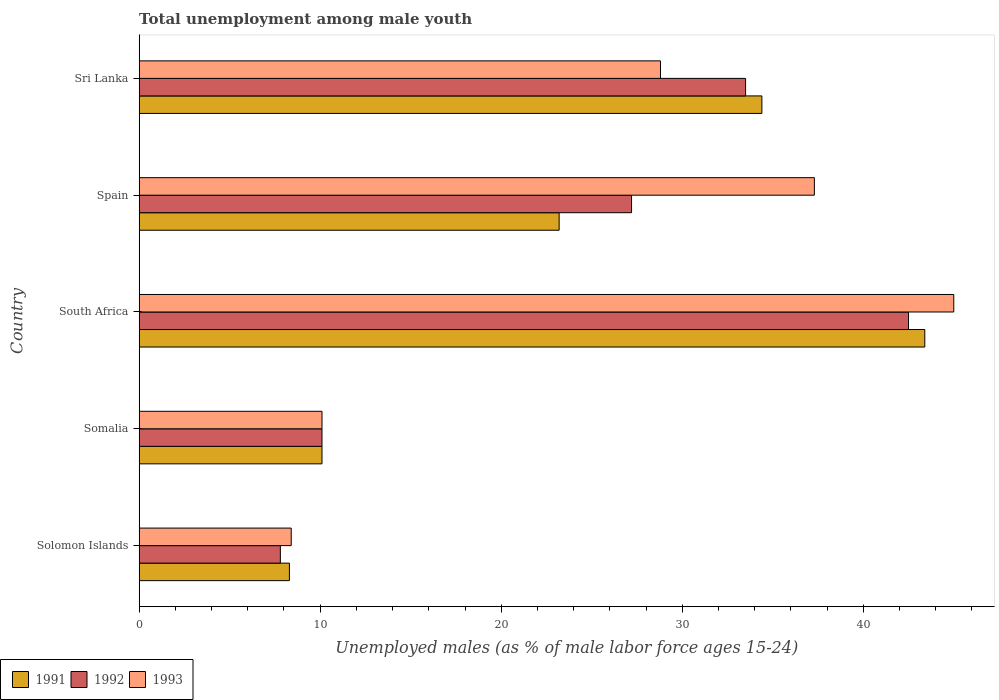How many different coloured bars are there?
Offer a very short reply. 3. Are the number of bars per tick equal to the number of legend labels?
Give a very brief answer. Yes. Are the number of bars on each tick of the Y-axis equal?
Provide a short and direct response. Yes. How many bars are there on the 4th tick from the top?
Your response must be concise. 3. What is the label of the 1st group of bars from the top?
Give a very brief answer. Sri Lanka. What is the percentage of unemployed males in in 1992 in Sri Lanka?
Ensure brevity in your answer.  33.5. Across all countries, what is the maximum percentage of unemployed males in in 1992?
Provide a succinct answer. 42.5. Across all countries, what is the minimum percentage of unemployed males in in 1993?
Provide a succinct answer. 8.4. In which country was the percentage of unemployed males in in 1992 maximum?
Offer a terse response. South Africa. In which country was the percentage of unemployed males in in 1993 minimum?
Provide a short and direct response. Solomon Islands. What is the total percentage of unemployed males in in 1993 in the graph?
Keep it short and to the point. 129.6. What is the difference between the percentage of unemployed males in in 1992 in Solomon Islands and that in Sri Lanka?
Keep it short and to the point. -25.7. What is the difference between the percentage of unemployed males in in 1992 in Solomon Islands and the percentage of unemployed males in in 1991 in South Africa?
Keep it short and to the point. -35.6. What is the average percentage of unemployed males in in 1993 per country?
Provide a succinct answer. 25.92. What is the difference between the percentage of unemployed males in in 1992 and percentage of unemployed males in in 1993 in Sri Lanka?
Make the answer very short. 4.7. In how many countries, is the percentage of unemployed males in in 1991 greater than 8 %?
Provide a succinct answer. 5. What is the ratio of the percentage of unemployed males in in 1991 in Solomon Islands to that in South Africa?
Offer a terse response. 0.19. Is the percentage of unemployed males in in 1992 in Spain less than that in Sri Lanka?
Make the answer very short. Yes. Is the difference between the percentage of unemployed males in in 1992 in Somalia and South Africa greater than the difference between the percentage of unemployed males in in 1993 in Somalia and South Africa?
Offer a very short reply. Yes. What is the difference between the highest and the second highest percentage of unemployed males in in 1993?
Keep it short and to the point. 7.7. What is the difference between the highest and the lowest percentage of unemployed males in in 1991?
Keep it short and to the point. 35.1. In how many countries, is the percentage of unemployed males in in 1991 greater than the average percentage of unemployed males in in 1991 taken over all countries?
Your response must be concise. 2. Is the sum of the percentage of unemployed males in in 1993 in Solomon Islands and South Africa greater than the maximum percentage of unemployed males in in 1991 across all countries?
Your response must be concise. Yes. What does the 2nd bar from the top in Spain represents?
Give a very brief answer. 1992. What does the 1st bar from the bottom in South Africa represents?
Offer a very short reply. 1991. Is it the case that in every country, the sum of the percentage of unemployed males in in 1992 and percentage of unemployed males in in 1993 is greater than the percentage of unemployed males in in 1991?
Give a very brief answer. Yes. Are all the bars in the graph horizontal?
Keep it short and to the point. Yes. How many countries are there in the graph?
Provide a short and direct response. 5. What is the difference between two consecutive major ticks on the X-axis?
Ensure brevity in your answer.  10. Are the values on the major ticks of X-axis written in scientific E-notation?
Ensure brevity in your answer.  No. Where does the legend appear in the graph?
Make the answer very short. Bottom left. What is the title of the graph?
Provide a short and direct response. Total unemployment among male youth. What is the label or title of the X-axis?
Your answer should be very brief. Unemployed males (as % of male labor force ages 15-24). What is the Unemployed males (as % of male labor force ages 15-24) of 1991 in Solomon Islands?
Ensure brevity in your answer.  8.3. What is the Unemployed males (as % of male labor force ages 15-24) of 1992 in Solomon Islands?
Make the answer very short. 7.8. What is the Unemployed males (as % of male labor force ages 15-24) of 1993 in Solomon Islands?
Give a very brief answer. 8.4. What is the Unemployed males (as % of male labor force ages 15-24) of 1991 in Somalia?
Provide a succinct answer. 10.1. What is the Unemployed males (as % of male labor force ages 15-24) of 1992 in Somalia?
Keep it short and to the point. 10.1. What is the Unemployed males (as % of male labor force ages 15-24) in 1993 in Somalia?
Give a very brief answer. 10.1. What is the Unemployed males (as % of male labor force ages 15-24) in 1991 in South Africa?
Offer a very short reply. 43.4. What is the Unemployed males (as % of male labor force ages 15-24) in 1992 in South Africa?
Provide a short and direct response. 42.5. What is the Unemployed males (as % of male labor force ages 15-24) in 1993 in South Africa?
Offer a terse response. 45. What is the Unemployed males (as % of male labor force ages 15-24) of 1991 in Spain?
Give a very brief answer. 23.2. What is the Unemployed males (as % of male labor force ages 15-24) of 1992 in Spain?
Keep it short and to the point. 27.2. What is the Unemployed males (as % of male labor force ages 15-24) in 1993 in Spain?
Offer a very short reply. 37.3. What is the Unemployed males (as % of male labor force ages 15-24) in 1991 in Sri Lanka?
Your answer should be compact. 34.4. What is the Unemployed males (as % of male labor force ages 15-24) of 1992 in Sri Lanka?
Your answer should be very brief. 33.5. What is the Unemployed males (as % of male labor force ages 15-24) of 1993 in Sri Lanka?
Offer a terse response. 28.8. Across all countries, what is the maximum Unemployed males (as % of male labor force ages 15-24) of 1991?
Provide a succinct answer. 43.4. Across all countries, what is the maximum Unemployed males (as % of male labor force ages 15-24) in 1992?
Provide a succinct answer. 42.5. Across all countries, what is the minimum Unemployed males (as % of male labor force ages 15-24) of 1991?
Offer a very short reply. 8.3. Across all countries, what is the minimum Unemployed males (as % of male labor force ages 15-24) in 1992?
Provide a short and direct response. 7.8. Across all countries, what is the minimum Unemployed males (as % of male labor force ages 15-24) of 1993?
Provide a short and direct response. 8.4. What is the total Unemployed males (as % of male labor force ages 15-24) in 1991 in the graph?
Provide a succinct answer. 119.4. What is the total Unemployed males (as % of male labor force ages 15-24) in 1992 in the graph?
Make the answer very short. 121.1. What is the total Unemployed males (as % of male labor force ages 15-24) of 1993 in the graph?
Offer a terse response. 129.6. What is the difference between the Unemployed males (as % of male labor force ages 15-24) of 1991 in Solomon Islands and that in Somalia?
Your answer should be very brief. -1.8. What is the difference between the Unemployed males (as % of male labor force ages 15-24) of 1992 in Solomon Islands and that in Somalia?
Provide a succinct answer. -2.3. What is the difference between the Unemployed males (as % of male labor force ages 15-24) in 1991 in Solomon Islands and that in South Africa?
Make the answer very short. -35.1. What is the difference between the Unemployed males (as % of male labor force ages 15-24) in 1992 in Solomon Islands and that in South Africa?
Your answer should be very brief. -34.7. What is the difference between the Unemployed males (as % of male labor force ages 15-24) of 1993 in Solomon Islands and that in South Africa?
Give a very brief answer. -36.6. What is the difference between the Unemployed males (as % of male labor force ages 15-24) in 1991 in Solomon Islands and that in Spain?
Provide a short and direct response. -14.9. What is the difference between the Unemployed males (as % of male labor force ages 15-24) in 1992 in Solomon Islands and that in Spain?
Your answer should be compact. -19.4. What is the difference between the Unemployed males (as % of male labor force ages 15-24) in 1993 in Solomon Islands and that in Spain?
Provide a short and direct response. -28.9. What is the difference between the Unemployed males (as % of male labor force ages 15-24) in 1991 in Solomon Islands and that in Sri Lanka?
Make the answer very short. -26.1. What is the difference between the Unemployed males (as % of male labor force ages 15-24) in 1992 in Solomon Islands and that in Sri Lanka?
Your answer should be very brief. -25.7. What is the difference between the Unemployed males (as % of male labor force ages 15-24) in 1993 in Solomon Islands and that in Sri Lanka?
Offer a very short reply. -20.4. What is the difference between the Unemployed males (as % of male labor force ages 15-24) of 1991 in Somalia and that in South Africa?
Ensure brevity in your answer.  -33.3. What is the difference between the Unemployed males (as % of male labor force ages 15-24) of 1992 in Somalia and that in South Africa?
Your answer should be compact. -32.4. What is the difference between the Unemployed males (as % of male labor force ages 15-24) in 1993 in Somalia and that in South Africa?
Ensure brevity in your answer.  -34.9. What is the difference between the Unemployed males (as % of male labor force ages 15-24) in 1992 in Somalia and that in Spain?
Provide a short and direct response. -17.1. What is the difference between the Unemployed males (as % of male labor force ages 15-24) of 1993 in Somalia and that in Spain?
Keep it short and to the point. -27.2. What is the difference between the Unemployed males (as % of male labor force ages 15-24) of 1991 in Somalia and that in Sri Lanka?
Make the answer very short. -24.3. What is the difference between the Unemployed males (as % of male labor force ages 15-24) of 1992 in Somalia and that in Sri Lanka?
Offer a terse response. -23.4. What is the difference between the Unemployed males (as % of male labor force ages 15-24) in 1993 in Somalia and that in Sri Lanka?
Make the answer very short. -18.7. What is the difference between the Unemployed males (as % of male labor force ages 15-24) of 1991 in South Africa and that in Spain?
Keep it short and to the point. 20.2. What is the difference between the Unemployed males (as % of male labor force ages 15-24) of 1992 in South Africa and that in Spain?
Provide a succinct answer. 15.3. What is the difference between the Unemployed males (as % of male labor force ages 15-24) of 1992 in South Africa and that in Sri Lanka?
Your response must be concise. 9. What is the difference between the Unemployed males (as % of male labor force ages 15-24) in 1993 in South Africa and that in Sri Lanka?
Keep it short and to the point. 16.2. What is the difference between the Unemployed males (as % of male labor force ages 15-24) in 1992 in Spain and that in Sri Lanka?
Give a very brief answer. -6.3. What is the difference between the Unemployed males (as % of male labor force ages 15-24) of 1991 in Solomon Islands and the Unemployed males (as % of male labor force ages 15-24) of 1993 in Somalia?
Your response must be concise. -1.8. What is the difference between the Unemployed males (as % of male labor force ages 15-24) in 1992 in Solomon Islands and the Unemployed males (as % of male labor force ages 15-24) in 1993 in Somalia?
Provide a succinct answer. -2.3. What is the difference between the Unemployed males (as % of male labor force ages 15-24) of 1991 in Solomon Islands and the Unemployed males (as % of male labor force ages 15-24) of 1992 in South Africa?
Your answer should be very brief. -34.2. What is the difference between the Unemployed males (as % of male labor force ages 15-24) in 1991 in Solomon Islands and the Unemployed males (as % of male labor force ages 15-24) in 1993 in South Africa?
Your answer should be compact. -36.7. What is the difference between the Unemployed males (as % of male labor force ages 15-24) of 1992 in Solomon Islands and the Unemployed males (as % of male labor force ages 15-24) of 1993 in South Africa?
Offer a terse response. -37.2. What is the difference between the Unemployed males (as % of male labor force ages 15-24) of 1991 in Solomon Islands and the Unemployed males (as % of male labor force ages 15-24) of 1992 in Spain?
Your response must be concise. -18.9. What is the difference between the Unemployed males (as % of male labor force ages 15-24) of 1991 in Solomon Islands and the Unemployed males (as % of male labor force ages 15-24) of 1993 in Spain?
Make the answer very short. -29. What is the difference between the Unemployed males (as % of male labor force ages 15-24) of 1992 in Solomon Islands and the Unemployed males (as % of male labor force ages 15-24) of 1993 in Spain?
Offer a very short reply. -29.5. What is the difference between the Unemployed males (as % of male labor force ages 15-24) of 1991 in Solomon Islands and the Unemployed males (as % of male labor force ages 15-24) of 1992 in Sri Lanka?
Provide a short and direct response. -25.2. What is the difference between the Unemployed males (as % of male labor force ages 15-24) of 1991 in Solomon Islands and the Unemployed males (as % of male labor force ages 15-24) of 1993 in Sri Lanka?
Give a very brief answer. -20.5. What is the difference between the Unemployed males (as % of male labor force ages 15-24) in 1992 in Solomon Islands and the Unemployed males (as % of male labor force ages 15-24) in 1993 in Sri Lanka?
Offer a terse response. -21. What is the difference between the Unemployed males (as % of male labor force ages 15-24) in 1991 in Somalia and the Unemployed males (as % of male labor force ages 15-24) in 1992 in South Africa?
Offer a very short reply. -32.4. What is the difference between the Unemployed males (as % of male labor force ages 15-24) in 1991 in Somalia and the Unemployed males (as % of male labor force ages 15-24) in 1993 in South Africa?
Your answer should be compact. -34.9. What is the difference between the Unemployed males (as % of male labor force ages 15-24) in 1992 in Somalia and the Unemployed males (as % of male labor force ages 15-24) in 1993 in South Africa?
Your answer should be compact. -34.9. What is the difference between the Unemployed males (as % of male labor force ages 15-24) in 1991 in Somalia and the Unemployed males (as % of male labor force ages 15-24) in 1992 in Spain?
Offer a terse response. -17.1. What is the difference between the Unemployed males (as % of male labor force ages 15-24) in 1991 in Somalia and the Unemployed males (as % of male labor force ages 15-24) in 1993 in Spain?
Provide a short and direct response. -27.2. What is the difference between the Unemployed males (as % of male labor force ages 15-24) in 1992 in Somalia and the Unemployed males (as % of male labor force ages 15-24) in 1993 in Spain?
Offer a very short reply. -27.2. What is the difference between the Unemployed males (as % of male labor force ages 15-24) of 1991 in Somalia and the Unemployed males (as % of male labor force ages 15-24) of 1992 in Sri Lanka?
Your answer should be very brief. -23.4. What is the difference between the Unemployed males (as % of male labor force ages 15-24) of 1991 in Somalia and the Unemployed males (as % of male labor force ages 15-24) of 1993 in Sri Lanka?
Keep it short and to the point. -18.7. What is the difference between the Unemployed males (as % of male labor force ages 15-24) in 1992 in Somalia and the Unemployed males (as % of male labor force ages 15-24) in 1993 in Sri Lanka?
Your answer should be very brief. -18.7. What is the difference between the Unemployed males (as % of male labor force ages 15-24) in 1991 in South Africa and the Unemployed males (as % of male labor force ages 15-24) in 1992 in Spain?
Your answer should be compact. 16.2. What is the difference between the Unemployed males (as % of male labor force ages 15-24) of 1991 in South Africa and the Unemployed males (as % of male labor force ages 15-24) of 1993 in Spain?
Provide a succinct answer. 6.1. What is the difference between the Unemployed males (as % of male labor force ages 15-24) in 1992 in South Africa and the Unemployed males (as % of male labor force ages 15-24) in 1993 in Spain?
Provide a succinct answer. 5.2. What is the difference between the Unemployed males (as % of male labor force ages 15-24) of 1991 in South Africa and the Unemployed males (as % of male labor force ages 15-24) of 1992 in Sri Lanka?
Offer a terse response. 9.9. What is the difference between the Unemployed males (as % of male labor force ages 15-24) of 1991 in South Africa and the Unemployed males (as % of male labor force ages 15-24) of 1993 in Sri Lanka?
Provide a short and direct response. 14.6. What is the difference between the Unemployed males (as % of male labor force ages 15-24) in 1991 in Spain and the Unemployed males (as % of male labor force ages 15-24) in 1992 in Sri Lanka?
Your response must be concise. -10.3. What is the difference between the Unemployed males (as % of male labor force ages 15-24) in 1991 in Spain and the Unemployed males (as % of male labor force ages 15-24) in 1993 in Sri Lanka?
Provide a short and direct response. -5.6. What is the average Unemployed males (as % of male labor force ages 15-24) of 1991 per country?
Ensure brevity in your answer.  23.88. What is the average Unemployed males (as % of male labor force ages 15-24) of 1992 per country?
Your response must be concise. 24.22. What is the average Unemployed males (as % of male labor force ages 15-24) of 1993 per country?
Offer a terse response. 25.92. What is the difference between the Unemployed males (as % of male labor force ages 15-24) in 1991 and Unemployed males (as % of male labor force ages 15-24) in 1992 in Solomon Islands?
Provide a short and direct response. 0.5. What is the difference between the Unemployed males (as % of male labor force ages 15-24) in 1991 and Unemployed males (as % of male labor force ages 15-24) in 1992 in Somalia?
Keep it short and to the point. 0. What is the difference between the Unemployed males (as % of male labor force ages 15-24) in 1991 and Unemployed males (as % of male labor force ages 15-24) in 1993 in South Africa?
Keep it short and to the point. -1.6. What is the difference between the Unemployed males (as % of male labor force ages 15-24) of 1991 and Unemployed males (as % of male labor force ages 15-24) of 1993 in Spain?
Give a very brief answer. -14.1. What is the difference between the Unemployed males (as % of male labor force ages 15-24) of 1991 and Unemployed males (as % of male labor force ages 15-24) of 1992 in Sri Lanka?
Your answer should be compact. 0.9. What is the difference between the Unemployed males (as % of male labor force ages 15-24) of 1991 and Unemployed males (as % of male labor force ages 15-24) of 1993 in Sri Lanka?
Make the answer very short. 5.6. What is the difference between the Unemployed males (as % of male labor force ages 15-24) of 1992 and Unemployed males (as % of male labor force ages 15-24) of 1993 in Sri Lanka?
Ensure brevity in your answer.  4.7. What is the ratio of the Unemployed males (as % of male labor force ages 15-24) in 1991 in Solomon Islands to that in Somalia?
Your answer should be compact. 0.82. What is the ratio of the Unemployed males (as % of male labor force ages 15-24) of 1992 in Solomon Islands to that in Somalia?
Offer a very short reply. 0.77. What is the ratio of the Unemployed males (as % of male labor force ages 15-24) in 1993 in Solomon Islands to that in Somalia?
Give a very brief answer. 0.83. What is the ratio of the Unemployed males (as % of male labor force ages 15-24) in 1991 in Solomon Islands to that in South Africa?
Keep it short and to the point. 0.19. What is the ratio of the Unemployed males (as % of male labor force ages 15-24) in 1992 in Solomon Islands to that in South Africa?
Offer a terse response. 0.18. What is the ratio of the Unemployed males (as % of male labor force ages 15-24) of 1993 in Solomon Islands to that in South Africa?
Your answer should be very brief. 0.19. What is the ratio of the Unemployed males (as % of male labor force ages 15-24) in 1991 in Solomon Islands to that in Spain?
Provide a short and direct response. 0.36. What is the ratio of the Unemployed males (as % of male labor force ages 15-24) in 1992 in Solomon Islands to that in Spain?
Keep it short and to the point. 0.29. What is the ratio of the Unemployed males (as % of male labor force ages 15-24) of 1993 in Solomon Islands to that in Spain?
Ensure brevity in your answer.  0.23. What is the ratio of the Unemployed males (as % of male labor force ages 15-24) in 1991 in Solomon Islands to that in Sri Lanka?
Offer a terse response. 0.24. What is the ratio of the Unemployed males (as % of male labor force ages 15-24) of 1992 in Solomon Islands to that in Sri Lanka?
Ensure brevity in your answer.  0.23. What is the ratio of the Unemployed males (as % of male labor force ages 15-24) of 1993 in Solomon Islands to that in Sri Lanka?
Provide a succinct answer. 0.29. What is the ratio of the Unemployed males (as % of male labor force ages 15-24) in 1991 in Somalia to that in South Africa?
Ensure brevity in your answer.  0.23. What is the ratio of the Unemployed males (as % of male labor force ages 15-24) in 1992 in Somalia to that in South Africa?
Ensure brevity in your answer.  0.24. What is the ratio of the Unemployed males (as % of male labor force ages 15-24) in 1993 in Somalia to that in South Africa?
Your response must be concise. 0.22. What is the ratio of the Unemployed males (as % of male labor force ages 15-24) of 1991 in Somalia to that in Spain?
Offer a terse response. 0.44. What is the ratio of the Unemployed males (as % of male labor force ages 15-24) in 1992 in Somalia to that in Spain?
Provide a short and direct response. 0.37. What is the ratio of the Unemployed males (as % of male labor force ages 15-24) in 1993 in Somalia to that in Spain?
Make the answer very short. 0.27. What is the ratio of the Unemployed males (as % of male labor force ages 15-24) in 1991 in Somalia to that in Sri Lanka?
Offer a terse response. 0.29. What is the ratio of the Unemployed males (as % of male labor force ages 15-24) of 1992 in Somalia to that in Sri Lanka?
Offer a very short reply. 0.3. What is the ratio of the Unemployed males (as % of male labor force ages 15-24) in 1993 in Somalia to that in Sri Lanka?
Offer a terse response. 0.35. What is the ratio of the Unemployed males (as % of male labor force ages 15-24) in 1991 in South Africa to that in Spain?
Your answer should be compact. 1.87. What is the ratio of the Unemployed males (as % of male labor force ages 15-24) of 1992 in South Africa to that in Spain?
Give a very brief answer. 1.56. What is the ratio of the Unemployed males (as % of male labor force ages 15-24) of 1993 in South Africa to that in Spain?
Your answer should be compact. 1.21. What is the ratio of the Unemployed males (as % of male labor force ages 15-24) of 1991 in South Africa to that in Sri Lanka?
Your answer should be very brief. 1.26. What is the ratio of the Unemployed males (as % of male labor force ages 15-24) of 1992 in South Africa to that in Sri Lanka?
Make the answer very short. 1.27. What is the ratio of the Unemployed males (as % of male labor force ages 15-24) in 1993 in South Africa to that in Sri Lanka?
Your answer should be compact. 1.56. What is the ratio of the Unemployed males (as % of male labor force ages 15-24) in 1991 in Spain to that in Sri Lanka?
Your response must be concise. 0.67. What is the ratio of the Unemployed males (as % of male labor force ages 15-24) of 1992 in Spain to that in Sri Lanka?
Provide a succinct answer. 0.81. What is the ratio of the Unemployed males (as % of male labor force ages 15-24) in 1993 in Spain to that in Sri Lanka?
Keep it short and to the point. 1.3. What is the difference between the highest and the second highest Unemployed males (as % of male labor force ages 15-24) in 1991?
Offer a very short reply. 9. What is the difference between the highest and the second highest Unemployed males (as % of male labor force ages 15-24) in 1992?
Provide a short and direct response. 9. What is the difference between the highest and the lowest Unemployed males (as % of male labor force ages 15-24) of 1991?
Keep it short and to the point. 35.1. What is the difference between the highest and the lowest Unemployed males (as % of male labor force ages 15-24) in 1992?
Offer a very short reply. 34.7. What is the difference between the highest and the lowest Unemployed males (as % of male labor force ages 15-24) in 1993?
Offer a terse response. 36.6. 